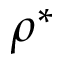Convert formula to latex. <formula><loc_0><loc_0><loc_500><loc_500>\rho ^ { * }</formula> 